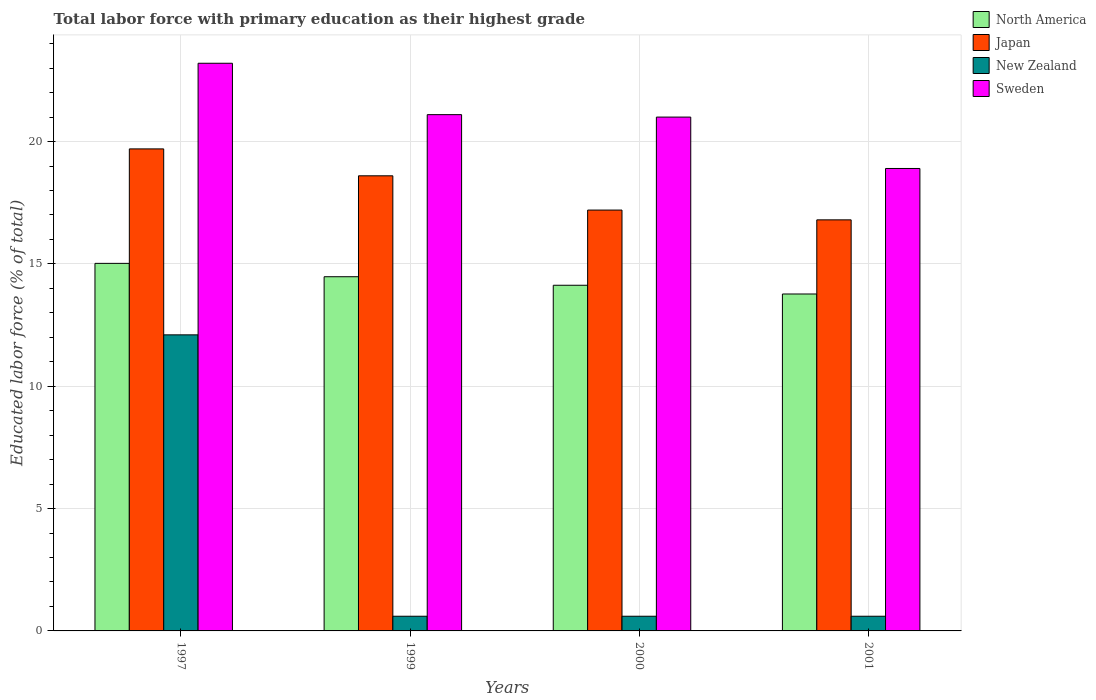Are the number of bars per tick equal to the number of legend labels?
Offer a very short reply. Yes. Are the number of bars on each tick of the X-axis equal?
Offer a terse response. Yes. How many bars are there on the 3rd tick from the left?
Give a very brief answer. 4. In how many cases, is the number of bars for a given year not equal to the number of legend labels?
Your response must be concise. 0. What is the percentage of total labor force with primary education in New Zealand in 2000?
Make the answer very short. 0.6. Across all years, what is the maximum percentage of total labor force with primary education in Sweden?
Your answer should be compact. 23.2. Across all years, what is the minimum percentage of total labor force with primary education in Japan?
Offer a terse response. 16.8. In which year was the percentage of total labor force with primary education in Japan minimum?
Keep it short and to the point. 2001. What is the total percentage of total labor force with primary education in Japan in the graph?
Offer a very short reply. 72.3. What is the difference between the percentage of total labor force with primary education in Sweden in 1997 and that in 1999?
Offer a very short reply. 2.1. What is the difference between the percentage of total labor force with primary education in Japan in 2000 and the percentage of total labor force with primary education in North America in 1997?
Provide a succinct answer. 2.18. What is the average percentage of total labor force with primary education in New Zealand per year?
Your answer should be compact. 3.48. In the year 1997, what is the difference between the percentage of total labor force with primary education in Sweden and percentage of total labor force with primary education in Japan?
Give a very brief answer. 3.5. In how many years, is the percentage of total labor force with primary education in Sweden greater than 4 %?
Your answer should be very brief. 4. What is the ratio of the percentage of total labor force with primary education in Sweden in 2000 to that in 2001?
Provide a short and direct response. 1.11. Is the percentage of total labor force with primary education in Japan in 1999 less than that in 2001?
Your response must be concise. No. Is the difference between the percentage of total labor force with primary education in Sweden in 1999 and 2001 greater than the difference between the percentage of total labor force with primary education in Japan in 1999 and 2001?
Your answer should be very brief. Yes. What is the difference between the highest and the second highest percentage of total labor force with primary education in Sweden?
Offer a very short reply. 2.1. What is the difference between the highest and the lowest percentage of total labor force with primary education in Japan?
Your answer should be very brief. 2.9. Is it the case that in every year, the sum of the percentage of total labor force with primary education in New Zealand and percentage of total labor force with primary education in Sweden is greater than the sum of percentage of total labor force with primary education in Japan and percentage of total labor force with primary education in North America?
Give a very brief answer. No. Is it the case that in every year, the sum of the percentage of total labor force with primary education in Sweden and percentage of total labor force with primary education in Japan is greater than the percentage of total labor force with primary education in New Zealand?
Provide a short and direct response. Yes. How many bars are there?
Ensure brevity in your answer.  16. Are all the bars in the graph horizontal?
Ensure brevity in your answer.  No. How many years are there in the graph?
Give a very brief answer. 4. What is the difference between two consecutive major ticks on the Y-axis?
Keep it short and to the point. 5. Are the values on the major ticks of Y-axis written in scientific E-notation?
Make the answer very short. No. Does the graph contain grids?
Your answer should be very brief. Yes. Where does the legend appear in the graph?
Provide a succinct answer. Top right. How are the legend labels stacked?
Provide a short and direct response. Vertical. What is the title of the graph?
Provide a short and direct response. Total labor force with primary education as their highest grade. What is the label or title of the X-axis?
Provide a short and direct response. Years. What is the label or title of the Y-axis?
Your response must be concise. Educated labor force (% of total). What is the Educated labor force (% of total) of North America in 1997?
Provide a succinct answer. 15.02. What is the Educated labor force (% of total) in Japan in 1997?
Provide a succinct answer. 19.7. What is the Educated labor force (% of total) of New Zealand in 1997?
Offer a very short reply. 12.1. What is the Educated labor force (% of total) of Sweden in 1997?
Ensure brevity in your answer.  23.2. What is the Educated labor force (% of total) in North America in 1999?
Offer a terse response. 14.48. What is the Educated labor force (% of total) in Japan in 1999?
Give a very brief answer. 18.6. What is the Educated labor force (% of total) of New Zealand in 1999?
Your response must be concise. 0.6. What is the Educated labor force (% of total) of Sweden in 1999?
Offer a terse response. 21.1. What is the Educated labor force (% of total) of North America in 2000?
Provide a short and direct response. 14.13. What is the Educated labor force (% of total) of Japan in 2000?
Your answer should be very brief. 17.2. What is the Educated labor force (% of total) in New Zealand in 2000?
Your response must be concise. 0.6. What is the Educated labor force (% of total) of Sweden in 2000?
Your answer should be very brief. 21. What is the Educated labor force (% of total) of North America in 2001?
Make the answer very short. 13.77. What is the Educated labor force (% of total) of Japan in 2001?
Provide a short and direct response. 16.8. What is the Educated labor force (% of total) of New Zealand in 2001?
Ensure brevity in your answer.  0.6. What is the Educated labor force (% of total) of Sweden in 2001?
Offer a terse response. 18.9. Across all years, what is the maximum Educated labor force (% of total) in North America?
Your response must be concise. 15.02. Across all years, what is the maximum Educated labor force (% of total) of Japan?
Make the answer very short. 19.7. Across all years, what is the maximum Educated labor force (% of total) in New Zealand?
Ensure brevity in your answer.  12.1. Across all years, what is the maximum Educated labor force (% of total) of Sweden?
Ensure brevity in your answer.  23.2. Across all years, what is the minimum Educated labor force (% of total) in North America?
Offer a very short reply. 13.77. Across all years, what is the minimum Educated labor force (% of total) in Japan?
Provide a succinct answer. 16.8. Across all years, what is the minimum Educated labor force (% of total) of New Zealand?
Your answer should be very brief. 0.6. Across all years, what is the minimum Educated labor force (% of total) in Sweden?
Provide a short and direct response. 18.9. What is the total Educated labor force (% of total) in North America in the graph?
Give a very brief answer. 57.39. What is the total Educated labor force (% of total) of Japan in the graph?
Provide a succinct answer. 72.3. What is the total Educated labor force (% of total) in New Zealand in the graph?
Ensure brevity in your answer.  13.9. What is the total Educated labor force (% of total) of Sweden in the graph?
Offer a terse response. 84.2. What is the difference between the Educated labor force (% of total) of North America in 1997 and that in 1999?
Provide a short and direct response. 0.55. What is the difference between the Educated labor force (% of total) in Sweden in 1997 and that in 1999?
Your answer should be compact. 2.1. What is the difference between the Educated labor force (% of total) of North America in 1997 and that in 2000?
Your answer should be compact. 0.89. What is the difference between the Educated labor force (% of total) in Japan in 1997 and that in 2000?
Ensure brevity in your answer.  2.5. What is the difference between the Educated labor force (% of total) in Sweden in 1997 and that in 2000?
Offer a very short reply. 2.2. What is the difference between the Educated labor force (% of total) of North America in 1997 and that in 2001?
Ensure brevity in your answer.  1.25. What is the difference between the Educated labor force (% of total) in Japan in 1997 and that in 2001?
Provide a succinct answer. 2.9. What is the difference between the Educated labor force (% of total) of New Zealand in 1997 and that in 2001?
Your response must be concise. 11.5. What is the difference between the Educated labor force (% of total) of Sweden in 1997 and that in 2001?
Provide a succinct answer. 4.3. What is the difference between the Educated labor force (% of total) of North America in 1999 and that in 2000?
Provide a succinct answer. 0.35. What is the difference between the Educated labor force (% of total) in Japan in 1999 and that in 2000?
Provide a succinct answer. 1.4. What is the difference between the Educated labor force (% of total) in North America in 1999 and that in 2001?
Make the answer very short. 0.71. What is the difference between the Educated labor force (% of total) in New Zealand in 1999 and that in 2001?
Provide a short and direct response. 0. What is the difference between the Educated labor force (% of total) in North America in 2000 and that in 2001?
Make the answer very short. 0.36. What is the difference between the Educated labor force (% of total) in Sweden in 2000 and that in 2001?
Your response must be concise. 2.1. What is the difference between the Educated labor force (% of total) in North America in 1997 and the Educated labor force (% of total) in Japan in 1999?
Your response must be concise. -3.58. What is the difference between the Educated labor force (% of total) in North America in 1997 and the Educated labor force (% of total) in New Zealand in 1999?
Your answer should be compact. 14.42. What is the difference between the Educated labor force (% of total) in North America in 1997 and the Educated labor force (% of total) in Sweden in 1999?
Make the answer very short. -6.08. What is the difference between the Educated labor force (% of total) of New Zealand in 1997 and the Educated labor force (% of total) of Sweden in 1999?
Keep it short and to the point. -9. What is the difference between the Educated labor force (% of total) in North America in 1997 and the Educated labor force (% of total) in Japan in 2000?
Provide a succinct answer. -2.18. What is the difference between the Educated labor force (% of total) in North America in 1997 and the Educated labor force (% of total) in New Zealand in 2000?
Ensure brevity in your answer.  14.42. What is the difference between the Educated labor force (% of total) of North America in 1997 and the Educated labor force (% of total) of Sweden in 2000?
Your answer should be compact. -5.98. What is the difference between the Educated labor force (% of total) of Japan in 1997 and the Educated labor force (% of total) of New Zealand in 2000?
Provide a succinct answer. 19.1. What is the difference between the Educated labor force (% of total) of New Zealand in 1997 and the Educated labor force (% of total) of Sweden in 2000?
Offer a very short reply. -8.9. What is the difference between the Educated labor force (% of total) in North America in 1997 and the Educated labor force (% of total) in Japan in 2001?
Make the answer very short. -1.78. What is the difference between the Educated labor force (% of total) of North America in 1997 and the Educated labor force (% of total) of New Zealand in 2001?
Provide a short and direct response. 14.42. What is the difference between the Educated labor force (% of total) of North America in 1997 and the Educated labor force (% of total) of Sweden in 2001?
Give a very brief answer. -3.88. What is the difference between the Educated labor force (% of total) in Japan in 1997 and the Educated labor force (% of total) in New Zealand in 2001?
Ensure brevity in your answer.  19.1. What is the difference between the Educated labor force (% of total) of New Zealand in 1997 and the Educated labor force (% of total) of Sweden in 2001?
Give a very brief answer. -6.8. What is the difference between the Educated labor force (% of total) in North America in 1999 and the Educated labor force (% of total) in Japan in 2000?
Offer a very short reply. -2.72. What is the difference between the Educated labor force (% of total) of North America in 1999 and the Educated labor force (% of total) of New Zealand in 2000?
Your answer should be very brief. 13.88. What is the difference between the Educated labor force (% of total) in North America in 1999 and the Educated labor force (% of total) in Sweden in 2000?
Offer a very short reply. -6.52. What is the difference between the Educated labor force (% of total) of Japan in 1999 and the Educated labor force (% of total) of New Zealand in 2000?
Provide a succinct answer. 18. What is the difference between the Educated labor force (% of total) in New Zealand in 1999 and the Educated labor force (% of total) in Sweden in 2000?
Offer a terse response. -20.4. What is the difference between the Educated labor force (% of total) of North America in 1999 and the Educated labor force (% of total) of Japan in 2001?
Provide a short and direct response. -2.32. What is the difference between the Educated labor force (% of total) of North America in 1999 and the Educated labor force (% of total) of New Zealand in 2001?
Ensure brevity in your answer.  13.88. What is the difference between the Educated labor force (% of total) in North America in 1999 and the Educated labor force (% of total) in Sweden in 2001?
Keep it short and to the point. -4.42. What is the difference between the Educated labor force (% of total) in Japan in 1999 and the Educated labor force (% of total) in New Zealand in 2001?
Your answer should be compact. 18. What is the difference between the Educated labor force (% of total) in Japan in 1999 and the Educated labor force (% of total) in Sweden in 2001?
Your response must be concise. -0.3. What is the difference between the Educated labor force (% of total) of New Zealand in 1999 and the Educated labor force (% of total) of Sweden in 2001?
Provide a succinct answer. -18.3. What is the difference between the Educated labor force (% of total) in North America in 2000 and the Educated labor force (% of total) in Japan in 2001?
Offer a terse response. -2.67. What is the difference between the Educated labor force (% of total) in North America in 2000 and the Educated labor force (% of total) in New Zealand in 2001?
Your response must be concise. 13.53. What is the difference between the Educated labor force (% of total) of North America in 2000 and the Educated labor force (% of total) of Sweden in 2001?
Offer a very short reply. -4.77. What is the difference between the Educated labor force (% of total) of Japan in 2000 and the Educated labor force (% of total) of New Zealand in 2001?
Offer a very short reply. 16.6. What is the difference between the Educated labor force (% of total) in New Zealand in 2000 and the Educated labor force (% of total) in Sweden in 2001?
Ensure brevity in your answer.  -18.3. What is the average Educated labor force (% of total) of North America per year?
Your answer should be compact. 14.35. What is the average Educated labor force (% of total) in Japan per year?
Provide a succinct answer. 18.07. What is the average Educated labor force (% of total) of New Zealand per year?
Your answer should be compact. 3.48. What is the average Educated labor force (% of total) in Sweden per year?
Ensure brevity in your answer.  21.05. In the year 1997, what is the difference between the Educated labor force (% of total) in North America and Educated labor force (% of total) in Japan?
Provide a short and direct response. -4.68. In the year 1997, what is the difference between the Educated labor force (% of total) of North America and Educated labor force (% of total) of New Zealand?
Offer a very short reply. 2.92. In the year 1997, what is the difference between the Educated labor force (% of total) in North America and Educated labor force (% of total) in Sweden?
Keep it short and to the point. -8.18. In the year 1997, what is the difference between the Educated labor force (% of total) of New Zealand and Educated labor force (% of total) of Sweden?
Your response must be concise. -11.1. In the year 1999, what is the difference between the Educated labor force (% of total) of North America and Educated labor force (% of total) of Japan?
Your response must be concise. -4.12. In the year 1999, what is the difference between the Educated labor force (% of total) of North America and Educated labor force (% of total) of New Zealand?
Give a very brief answer. 13.88. In the year 1999, what is the difference between the Educated labor force (% of total) of North America and Educated labor force (% of total) of Sweden?
Offer a very short reply. -6.62. In the year 1999, what is the difference between the Educated labor force (% of total) of Japan and Educated labor force (% of total) of Sweden?
Provide a short and direct response. -2.5. In the year 1999, what is the difference between the Educated labor force (% of total) in New Zealand and Educated labor force (% of total) in Sweden?
Provide a short and direct response. -20.5. In the year 2000, what is the difference between the Educated labor force (% of total) in North America and Educated labor force (% of total) in Japan?
Ensure brevity in your answer.  -3.07. In the year 2000, what is the difference between the Educated labor force (% of total) of North America and Educated labor force (% of total) of New Zealand?
Your answer should be compact. 13.53. In the year 2000, what is the difference between the Educated labor force (% of total) in North America and Educated labor force (% of total) in Sweden?
Provide a short and direct response. -6.87. In the year 2000, what is the difference between the Educated labor force (% of total) in New Zealand and Educated labor force (% of total) in Sweden?
Provide a succinct answer. -20.4. In the year 2001, what is the difference between the Educated labor force (% of total) of North America and Educated labor force (% of total) of Japan?
Provide a succinct answer. -3.03. In the year 2001, what is the difference between the Educated labor force (% of total) in North America and Educated labor force (% of total) in New Zealand?
Offer a terse response. 13.17. In the year 2001, what is the difference between the Educated labor force (% of total) in North America and Educated labor force (% of total) in Sweden?
Make the answer very short. -5.13. In the year 2001, what is the difference between the Educated labor force (% of total) of Japan and Educated labor force (% of total) of New Zealand?
Offer a very short reply. 16.2. In the year 2001, what is the difference between the Educated labor force (% of total) of Japan and Educated labor force (% of total) of Sweden?
Give a very brief answer. -2.1. In the year 2001, what is the difference between the Educated labor force (% of total) in New Zealand and Educated labor force (% of total) in Sweden?
Offer a very short reply. -18.3. What is the ratio of the Educated labor force (% of total) in North America in 1997 to that in 1999?
Offer a terse response. 1.04. What is the ratio of the Educated labor force (% of total) of Japan in 1997 to that in 1999?
Ensure brevity in your answer.  1.06. What is the ratio of the Educated labor force (% of total) in New Zealand in 1997 to that in 1999?
Your answer should be compact. 20.17. What is the ratio of the Educated labor force (% of total) in Sweden in 1997 to that in 1999?
Ensure brevity in your answer.  1.1. What is the ratio of the Educated labor force (% of total) of North America in 1997 to that in 2000?
Keep it short and to the point. 1.06. What is the ratio of the Educated labor force (% of total) in Japan in 1997 to that in 2000?
Your response must be concise. 1.15. What is the ratio of the Educated labor force (% of total) of New Zealand in 1997 to that in 2000?
Your answer should be compact. 20.17. What is the ratio of the Educated labor force (% of total) of Sweden in 1997 to that in 2000?
Your answer should be very brief. 1.1. What is the ratio of the Educated labor force (% of total) in Japan in 1997 to that in 2001?
Ensure brevity in your answer.  1.17. What is the ratio of the Educated labor force (% of total) of New Zealand in 1997 to that in 2001?
Provide a succinct answer. 20.17. What is the ratio of the Educated labor force (% of total) of Sweden in 1997 to that in 2001?
Provide a short and direct response. 1.23. What is the ratio of the Educated labor force (% of total) in North America in 1999 to that in 2000?
Provide a succinct answer. 1.02. What is the ratio of the Educated labor force (% of total) in Japan in 1999 to that in 2000?
Give a very brief answer. 1.08. What is the ratio of the Educated labor force (% of total) in New Zealand in 1999 to that in 2000?
Your answer should be compact. 1. What is the ratio of the Educated labor force (% of total) of Sweden in 1999 to that in 2000?
Ensure brevity in your answer.  1. What is the ratio of the Educated labor force (% of total) of North America in 1999 to that in 2001?
Offer a very short reply. 1.05. What is the ratio of the Educated labor force (% of total) in Japan in 1999 to that in 2001?
Offer a terse response. 1.11. What is the ratio of the Educated labor force (% of total) of Sweden in 1999 to that in 2001?
Provide a succinct answer. 1.12. What is the ratio of the Educated labor force (% of total) in North America in 2000 to that in 2001?
Provide a succinct answer. 1.03. What is the ratio of the Educated labor force (% of total) of Japan in 2000 to that in 2001?
Give a very brief answer. 1.02. What is the difference between the highest and the second highest Educated labor force (% of total) of North America?
Offer a very short reply. 0.55. What is the difference between the highest and the second highest Educated labor force (% of total) of New Zealand?
Give a very brief answer. 11.5. What is the difference between the highest and the second highest Educated labor force (% of total) of Sweden?
Your answer should be compact. 2.1. What is the difference between the highest and the lowest Educated labor force (% of total) of North America?
Your answer should be very brief. 1.25. What is the difference between the highest and the lowest Educated labor force (% of total) of Japan?
Your answer should be compact. 2.9. What is the difference between the highest and the lowest Educated labor force (% of total) of Sweden?
Provide a short and direct response. 4.3. 